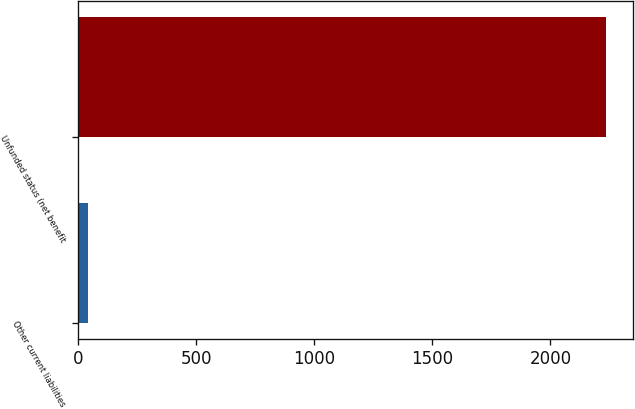Convert chart. <chart><loc_0><loc_0><loc_500><loc_500><bar_chart><fcel>Other current liabilities<fcel>Unfunded status (net benefit<nl><fcel>42<fcel>2236<nl></chart> 